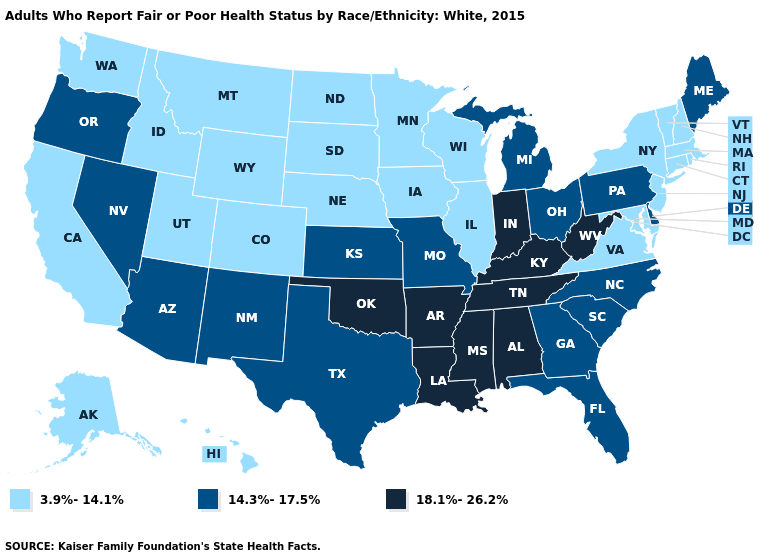Does the map have missing data?
Quick response, please. No. Does Mississippi have a higher value than Kentucky?
Keep it brief. No. What is the lowest value in the MidWest?
Give a very brief answer. 3.9%-14.1%. What is the lowest value in the South?
Answer briefly. 3.9%-14.1%. What is the value of Missouri?
Short answer required. 14.3%-17.5%. Name the states that have a value in the range 18.1%-26.2%?
Give a very brief answer. Alabama, Arkansas, Indiana, Kentucky, Louisiana, Mississippi, Oklahoma, Tennessee, West Virginia. What is the value of Nebraska?
Short answer required. 3.9%-14.1%. Is the legend a continuous bar?
Quick response, please. No. Which states have the lowest value in the South?
Answer briefly. Maryland, Virginia. How many symbols are there in the legend?
Be succinct. 3. What is the value of Louisiana?
Short answer required. 18.1%-26.2%. Does Hawaii have the same value as Texas?
Give a very brief answer. No. Does New Mexico have the lowest value in the West?
Be succinct. No. What is the highest value in the USA?
Be succinct. 18.1%-26.2%. Name the states that have a value in the range 18.1%-26.2%?
Give a very brief answer. Alabama, Arkansas, Indiana, Kentucky, Louisiana, Mississippi, Oklahoma, Tennessee, West Virginia. 